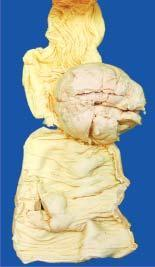s the polypoid growth seen projecting into lumen while the covering mucosa is ulcerated?
Answer the question using a single word or phrase. Yes 